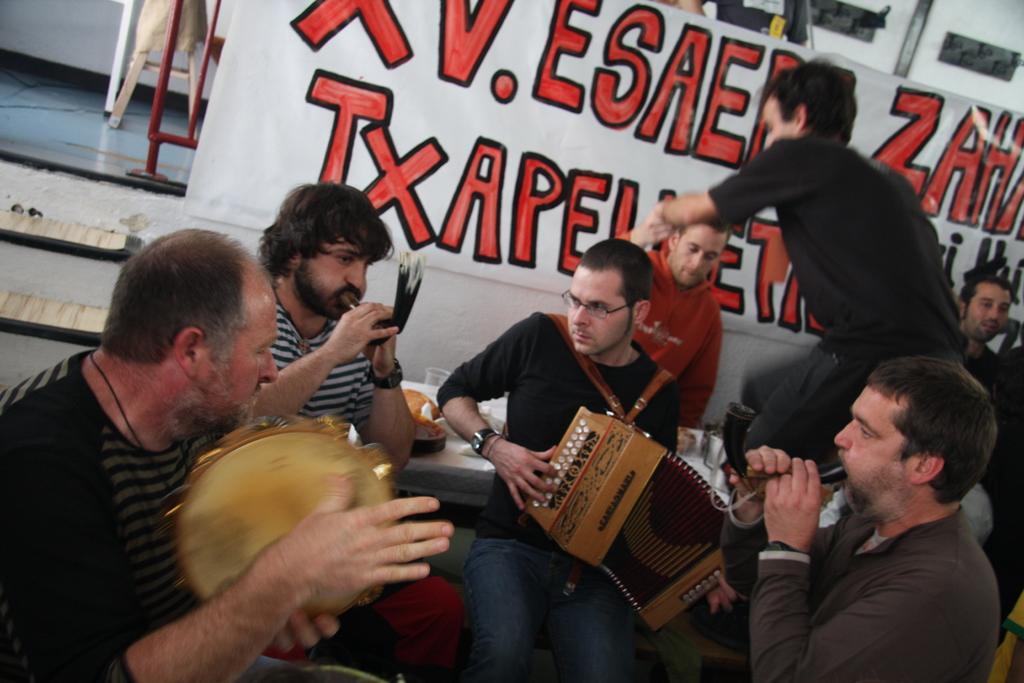Describe this image in one or two sentences. In this picture there are group of people who are playing musical instruments and sitting on the chair. There is a man standing. There is a cup and few things on the table. There is a banner at the background. 